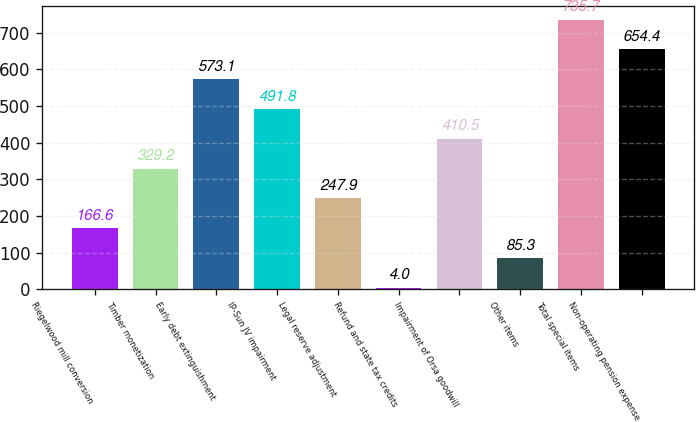Convert chart. <chart><loc_0><loc_0><loc_500><loc_500><bar_chart><fcel>Riegelwood mill conversion<fcel>Timber monetization<fcel>Early debt extinguishment<fcel>IP-Sun JV impairment<fcel>Legal reserve adjustment<fcel>Refund and state tax credits<fcel>Impairment of Orsa goodwill<fcel>Other items<fcel>Total special items<fcel>Non-operating pension expense<nl><fcel>166.6<fcel>329.2<fcel>573.1<fcel>491.8<fcel>247.9<fcel>4<fcel>410.5<fcel>85.3<fcel>735.7<fcel>654.4<nl></chart> 